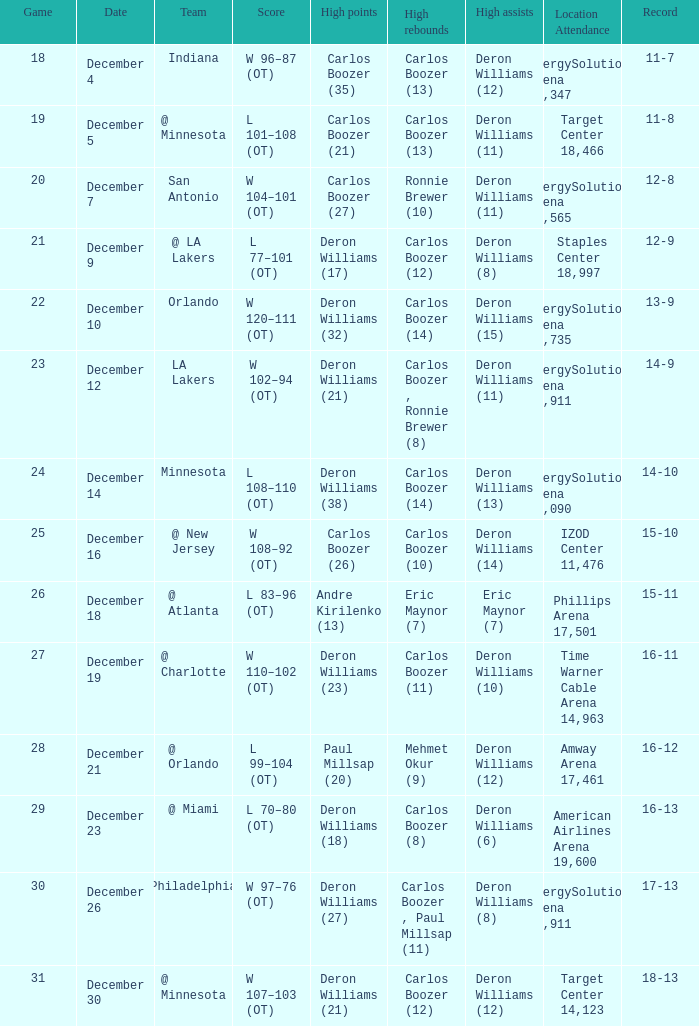Could you parse the entire table? {'header': ['Game', 'Date', 'Team', 'Score', 'High points', 'High rebounds', 'High assists', 'Location Attendance', 'Record'], 'rows': [['18', 'December 4', 'Indiana', 'W 96–87 (OT)', 'Carlos Boozer (35)', 'Carlos Boozer (13)', 'Deron Williams (12)', 'EnergySolutions Arena 19,347', '11-7'], ['19', 'December 5', '@ Minnesota', 'L 101–108 (OT)', 'Carlos Boozer (21)', 'Carlos Boozer (13)', 'Deron Williams (11)', 'Target Center 18,466', '11-8'], ['20', 'December 7', 'San Antonio', 'W 104–101 (OT)', 'Carlos Boozer (27)', 'Ronnie Brewer (10)', 'Deron Williams (11)', 'EnergySolutions Arena 17,565', '12-8'], ['21', 'December 9', '@ LA Lakers', 'L 77–101 (OT)', 'Deron Williams (17)', 'Carlos Boozer (12)', 'Deron Williams (8)', 'Staples Center 18,997', '12-9'], ['22', 'December 10', 'Orlando', 'W 120–111 (OT)', 'Deron Williams (32)', 'Carlos Boozer (14)', 'Deron Williams (15)', 'EnergySolutions Arena 18,735', '13-9'], ['23', 'December 12', 'LA Lakers', 'W 102–94 (OT)', 'Deron Williams (21)', 'Carlos Boozer , Ronnie Brewer (8)', 'Deron Williams (11)', 'EnergySolutions Arena 19,911', '14-9'], ['24', 'December 14', 'Minnesota', 'L 108–110 (OT)', 'Deron Williams (38)', 'Carlos Boozer (14)', 'Deron Williams (13)', 'EnergySolutions Arena 18,090', '14-10'], ['25', 'December 16', '@ New Jersey', 'W 108–92 (OT)', 'Carlos Boozer (26)', 'Carlos Boozer (10)', 'Deron Williams (14)', 'IZOD Center 11,476', '15-10'], ['26', 'December 18', '@ Atlanta', 'L 83–96 (OT)', 'Andre Kirilenko (13)', 'Eric Maynor (7)', 'Eric Maynor (7)', 'Phillips Arena 17,501', '15-11'], ['27', 'December 19', '@ Charlotte', 'W 110–102 (OT)', 'Deron Williams (23)', 'Carlos Boozer (11)', 'Deron Williams (10)', 'Time Warner Cable Arena 14,963', '16-11'], ['28', 'December 21', '@ Orlando', 'L 99–104 (OT)', 'Paul Millsap (20)', 'Mehmet Okur (9)', 'Deron Williams (12)', 'Amway Arena 17,461', '16-12'], ['29', 'December 23', '@ Miami', 'L 70–80 (OT)', 'Deron Williams (18)', 'Carlos Boozer (8)', 'Deron Williams (6)', 'American Airlines Arena 19,600', '16-13'], ['30', 'December 26', 'Philadelphia', 'W 97–76 (OT)', 'Deron Williams (27)', 'Carlos Boozer , Paul Millsap (11)', 'Deron Williams (8)', 'EnergySolutions Arena 19,911', '17-13'], ['31', 'December 30', '@ Minnesota', 'W 107–103 (OT)', 'Deron Williams (21)', 'Carlos Boozer (12)', 'Deron Williams (12)', 'Target Center 14,123', '18-13']]} How many different high rebound results are there for the game number 26? 1.0. 